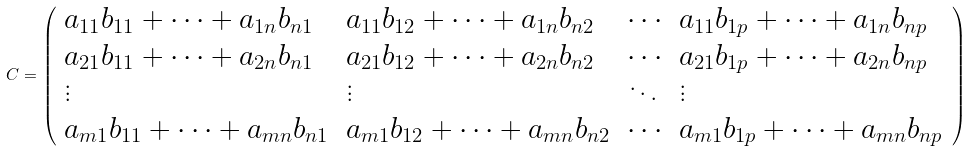Convert formula to latex. <formula><loc_0><loc_0><loc_500><loc_500>C = { \left ( \begin{array} { l l l l } { a _ { 1 1 } b _ { 1 1 } + \cdots + a _ { 1 n } b _ { n 1 } } & { a _ { 1 1 } b _ { 1 2 } + \cdots + a _ { 1 n } b _ { n 2 } } & { \cdots } & { a _ { 1 1 } b _ { 1 p } + \cdots + a _ { 1 n } b _ { n p } } \\ { a _ { 2 1 } b _ { 1 1 } + \cdots + a _ { 2 n } b _ { n 1 } } & { a _ { 2 1 } b _ { 1 2 } + \cdots + a _ { 2 n } b _ { n 2 } } & { \cdots } & { a _ { 2 1 } b _ { 1 p } + \cdots + a _ { 2 n } b _ { n p } } \\ { \vdots } & { \vdots } & { \ddots } & { \vdots } \\ { a _ { m 1 } b _ { 1 1 } + \cdots + a _ { m n } b _ { n 1 } } & { a _ { m 1 } b _ { 1 2 } + \cdots + a _ { m n } b _ { n 2 } } & { \cdots } & { a _ { m 1 } b _ { 1 p } + \cdots + a _ { m n } b _ { n p } } \end{array} \right ) }</formula> 